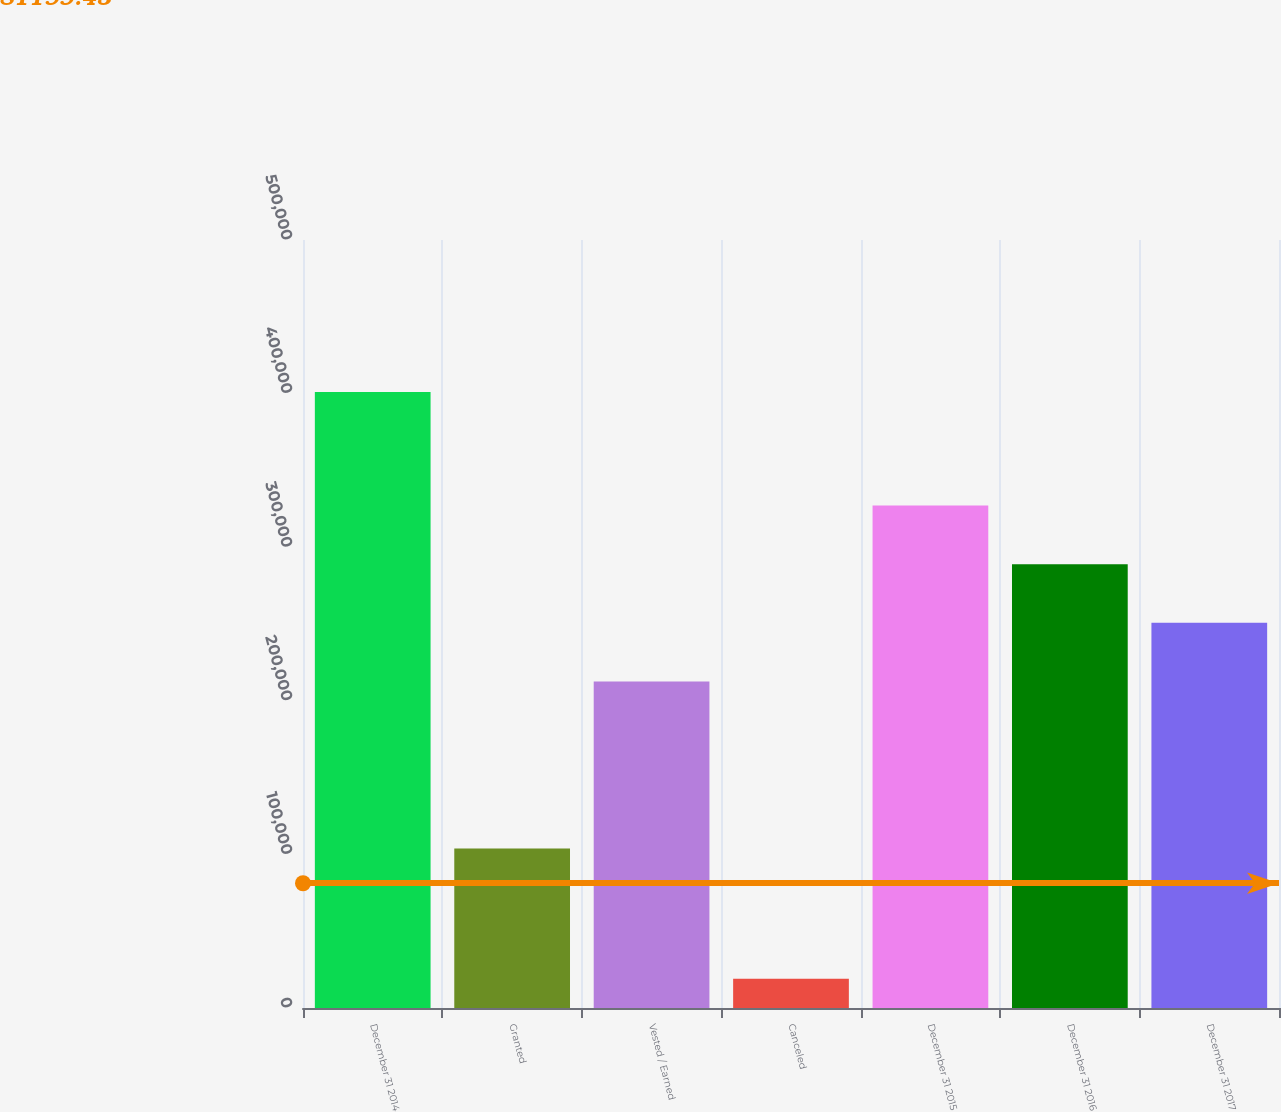Convert chart to OTSL. <chart><loc_0><loc_0><loc_500><loc_500><bar_chart><fcel>December 31 2014<fcel>Granted<fcel>Vested / Earned<fcel>Canceled<fcel>December 31 2015<fcel>December 31 2016<fcel>December 31 2017<nl><fcel>401071<fcel>103841<fcel>212576<fcel>19101<fcel>327167<fcel>288970<fcel>250773<nl></chart> 